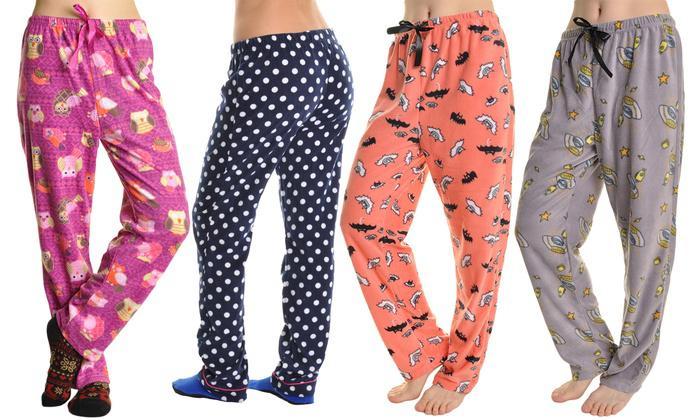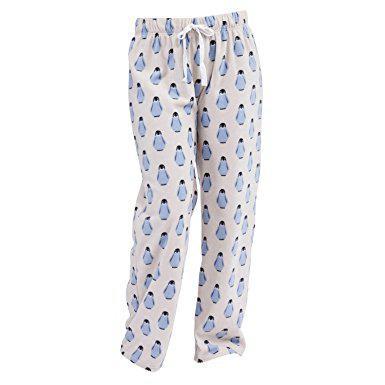The first image is the image on the left, the second image is the image on the right. Examine the images to the left and right. Is the description "One image features pajama pants with a square pattern." accurate? Answer yes or no. No. 